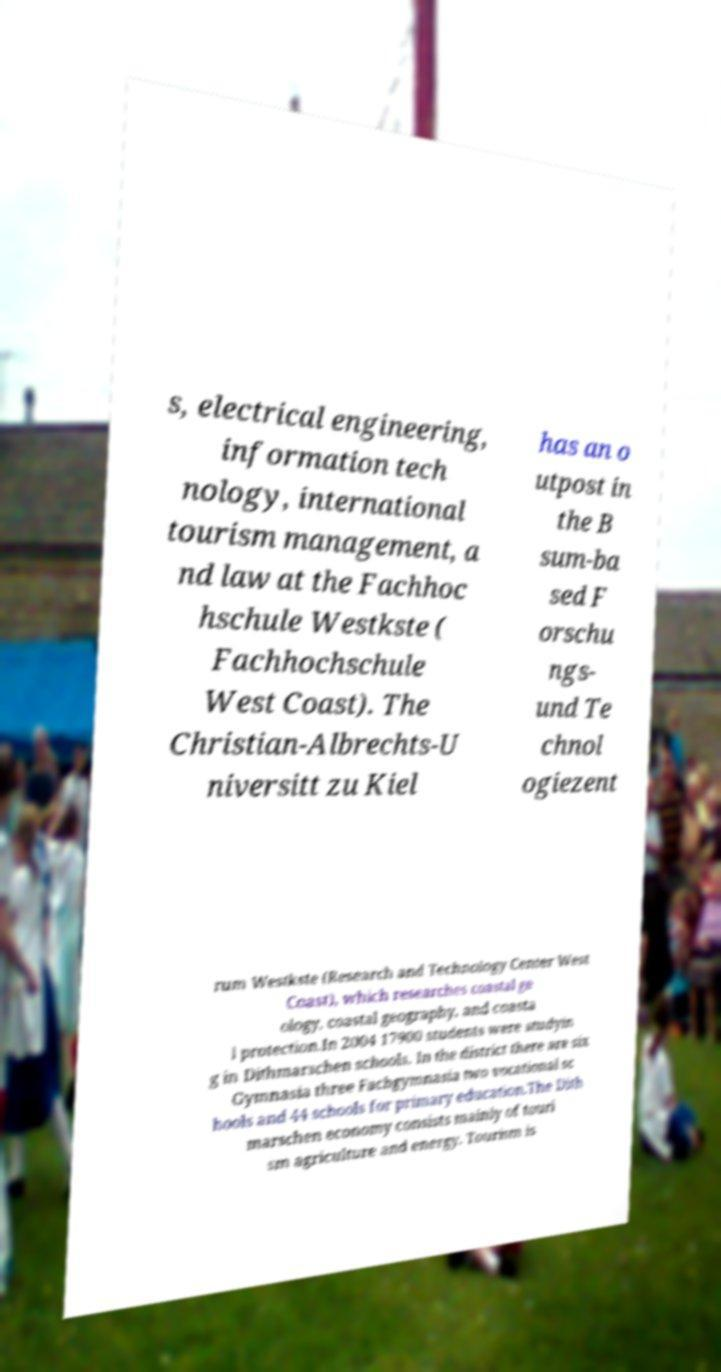What messages or text are displayed in this image? I need them in a readable, typed format. s, electrical engineering, information tech nology, international tourism management, a nd law at the Fachhoc hschule Westkste ( Fachhochschule West Coast). The Christian-Albrechts-U niversitt zu Kiel has an o utpost in the B sum-ba sed F orschu ngs- und Te chnol ogiezent rum Westkste (Research and Technology Center West Coast), which researches coastal ge ology, coastal geography, and coasta l protection.In 2004 17900 students were studyin g in Dithmarschen schools. In the district there are six Gymnasia three Fachgymnasia two vocational sc hools and 44 schools for primary education.The Dith marschen economy consists mainly of touri sm agriculture and energy. Tourism is 